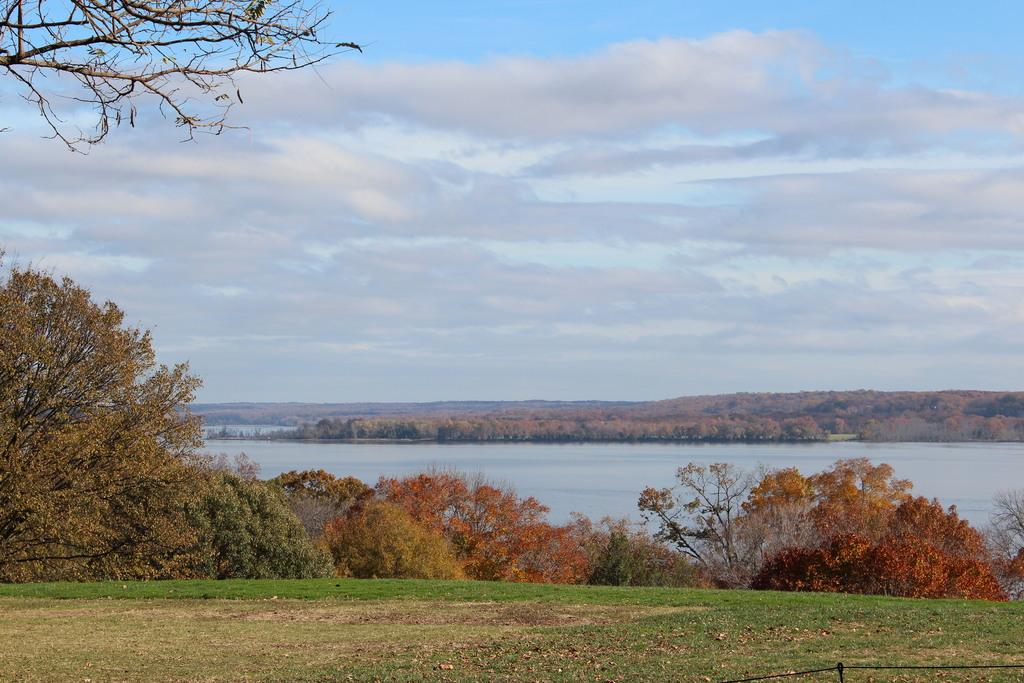What natural element is visible in the image? Water is visible in the image. What type of vegetation can be seen in the image? There are trees and grass in the image. What geographical feature is present in the image? There are hills in the image. What part of the natural environment is visible in the image? The sky is visible in the image. What atmospheric conditions can be observed in the sky? Clouds are present in the sky. Can you tell me how many quince trees are in the image? There is no mention of quince trees in the image, so it is not possible to determine their number. 